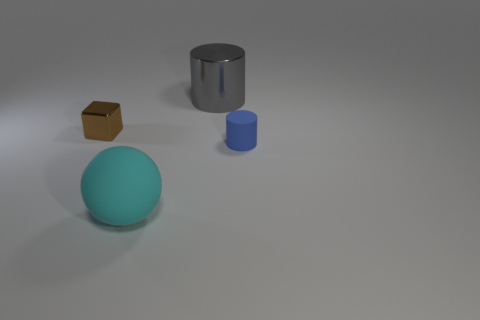There is a sphere; is it the same color as the object left of the cyan matte sphere?
Your answer should be very brief. No. What color is the big shiny thing?
Offer a very short reply. Gray. How many things are blue metallic objects or tiny cylinders?
Ensure brevity in your answer.  1. There is a brown cube that is the same size as the blue object; what is it made of?
Give a very brief answer. Metal. There is a matte object that is on the right side of the large gray shiny object; what size is it?
Give a very brief answer. Small. What material is the cyan ball?
Provide a succinct answer. Rubber. What number of things are things that are behind the big rubber sphere or large things that are in front of the small rubber cylinder?
Your answer should be compact. 4. Does the cyan rubber object have the same shape as the object behind the small shiny thing?
Offer a terse response. No. Are there fewer big metallic things that are in front of the large gray shiny cylinder than tiny blue matte cylinders in front of the cyan rubber thing?
Make the answer very short. No. There is another thing that is the same shape as the gray object; what is its material?
Offer a terse response. Rubber. 